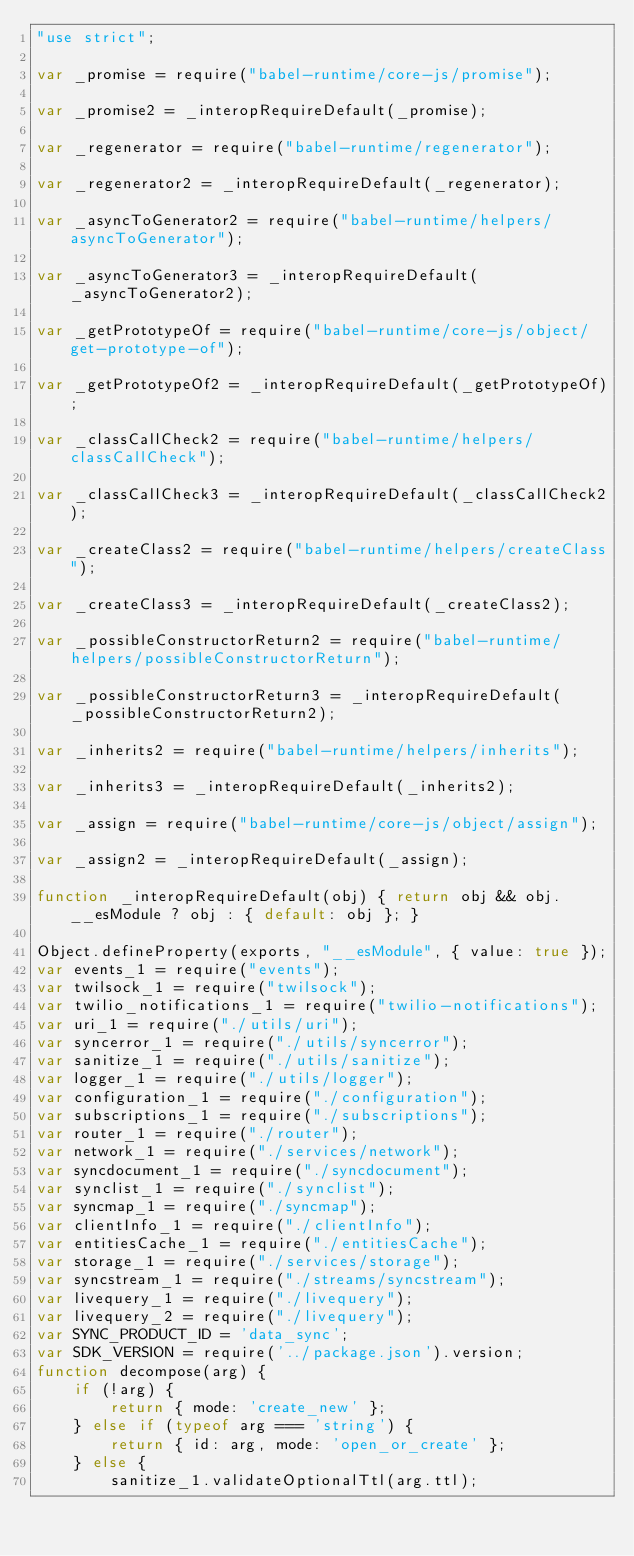<code> <loc_0><loc_0><loc_500><loc_500><_JavaScript_>"use strict";

var _promise = require("babel-runtime/core-js/promise");

var _promise2 = _interopRequireDefault(_promise);

var _regenerator = require("babel-runtime/regenerator");

var _regenerator2 = _interopRequireDefault(_regenerator);

var _asyncToGenerator2 = require("babel-runtime/helpers/asyncToGenerator");

var _asyncToGenerator3 = _interopRequireDefault(_asyncToGenerator2);

var _getPrototypeOf = require("babel-runtime/core-js/object/get-prototype-of");

var _getPrototypeOf2 = _interopRequireDefault(_getPrototypeOf);

var _classCallCheck2 = require("babel-runtime/helpers/classCallCheck");

var _classCallCheck3 = _interopRequireDefault(_classCallCheck2);

var _createClass2 = require("babel-runtime/helpers/createClass");

var _createClass3 = _interopRequireDefault(_createClass2);

var _possibleConstructorReturn2 = require("babel-runtime/helpers/possibleConstructorReturn");

var _possibleConstructorReturn3 = _interopRequireDefault(_possibleConstructorReturn2);

var _inherits2 = require("babel-runtime/helpers/inherits");

var _inherits3 = _interopRequireDefault(_inherits2);

var _assign = require("babel-runtime/core-js/object/assign");

var _assign2 = _interopRequireDefault(_assign);

function _interopRequireDefault(obj) { return obj && obj.__esModule ? obj : { default: obj }; }

Object.defineProperty(exports, "__esModule", { value: true });
var events_1 = require("events");
var twilsock_1 = require("twilsock");
var twilio_notifications_1 = require("twilio-notifications");
var uri_1 = require("./utils/uri");
var syncerror_1 = require("./utils/syncerror");
var sanitize_1 = require("./utils/sanitize");
var logger_1 = require("./utils/logger");
var configuration_1 = require("./configuration");
var subscriptions_1 = require("./subscriptions");
var router_1 = require("./router");
var network_1 = require("./services/network");
var syncdocument_1 = require("./syncdocument");
var synclist_1 = require("./synclist");
var syncmap_1 = require("./syncmap");
var clientInfo_1 = require("./clientInfo");
var entitiesCache_1 = require("./entitiesCache");
var storage_1 = require("./services/storage");
var syncstream_1 = require("./streams/syncstream");
var livequery_1 = require("./livequery");
var livequery_2 = require("./livequery");
var SYNC_PRODUCT_ID = 'data_sync';
var SDK_VERSION = require('../package.json').version;
function decompose(arg) {
    if (!arg) {
        return { mode: 'create_new' };
    } else if (typeof arg === 'string') {
        return { id: arg, mode: 'open_or_create' };
    } else {
        sanitize_1.validateOptionalTtl(arg.ttl);</code> 